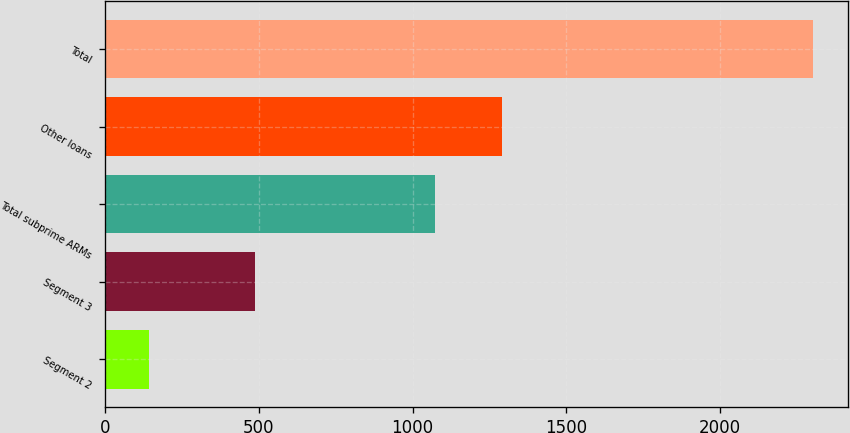Convert chart to OTSL. <chart><loc_0><loc_0><loc_500><loc_500><bar_chart><fcel>Segment 2<fcel>Segment 3<fcel>Total subprime ARMs<fcel>Other loans<fcel>Total<nl><fcel>142<fcel>489<fcel>1074<fcel>1290<fcel>2302<nl></chart> 